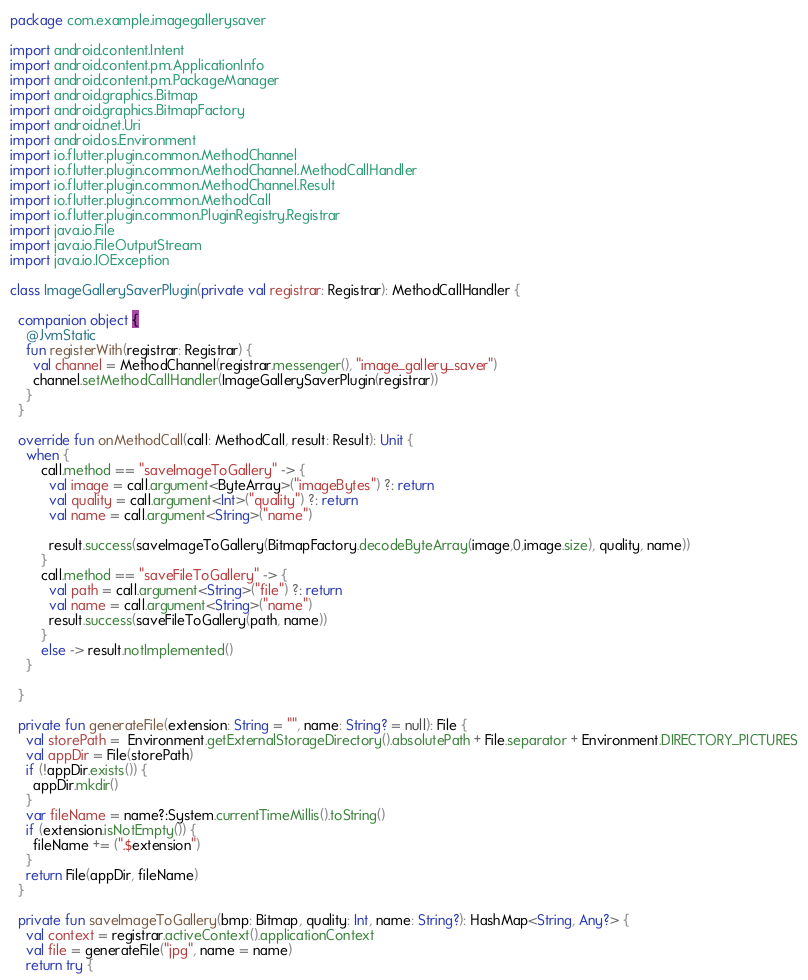Convert code to text. <code><loc_0><loc_0><loc_500><loc_500><_Kotlin_>package com.example.imagegallerysaver

import android.content.Intent
import android.content.pm.ApplicationInfo
import android.content.pm.PackageManager
import android.graphics.Bitmap
import android.graphics.BitmapFactory
import android.net.Uri
import android.os.Environment
import io.flutter.plugin.common.MethodChannel
import io.flutter.plugin.common.MethodChannel.MethodCallHandler
import io.flutter.plugin.common.MethodChannel.Result
import io.flutter.plugin.common.MethodCall
import io.flutter.plugin.common.PluginRegistry.Registrar
import java.io.File
import java.io.FileOutputStream
import java.io.IOException

class ImageGallerySaverPlugin(private val registrar: Registrar): MethodCallHandler {

  companion object {
    @JvmStatic
    fun registerWith(registrar: Registrar) {
      val channel = MethodChannel(registrar.messenger(), "image_gallery_saver")
      channel.setMethodCallHandler(ImageGallerySaverPlugin(registrar))
    }
  }

  override fun onMethodCall(call: MethodCall, result: Result): Unit {
    when {
        call.method == "saveImageToGallery" -> {
          val image = call.argument<ByteArray>("imageBytes") ?: return
          val quality = call.argument<Int>("quality") ?: return
          val name = call.argument<String>("name")

          result.success(saveImageToGallery(BitmapFactory.decodeByteArray(image,0,image.size), quality, name))
        }
        call.method == "saveFileToGallery" -> {
          val path = call.argument<String>("file") ?: return
          val name = call.argument<String>("name")
          result.success(saveFileToGallery(path, name))
        }
        else -> result.notImplemented()
    }

  }

  private fun generateFile(extension: String = "", name: String? = null): File {
    val storePath =  Environment.getExternalStorageDirectory().absolutePath + File.separator + Environment.DIRECTORY_PICTURES
    val appDir = File(storePath)
    if (!appDir.exists()) {
      appDir.mkdir()
    }
    var fileName = name?:System.currentTimeMillis().toString()
    if (extension.isNotEmpty()) {
      fileName += (".$extension")
    }
    return File(appDir, fileName)
  }

  private fun saveImageToGallery(bmp: Bitmap, quality: Int, name: String?): HashMap<String, Any?> {
    val context = registrar.activeContext().applicationContext
    val file = generateFile("jpg", name = name)
    return try {</code> 